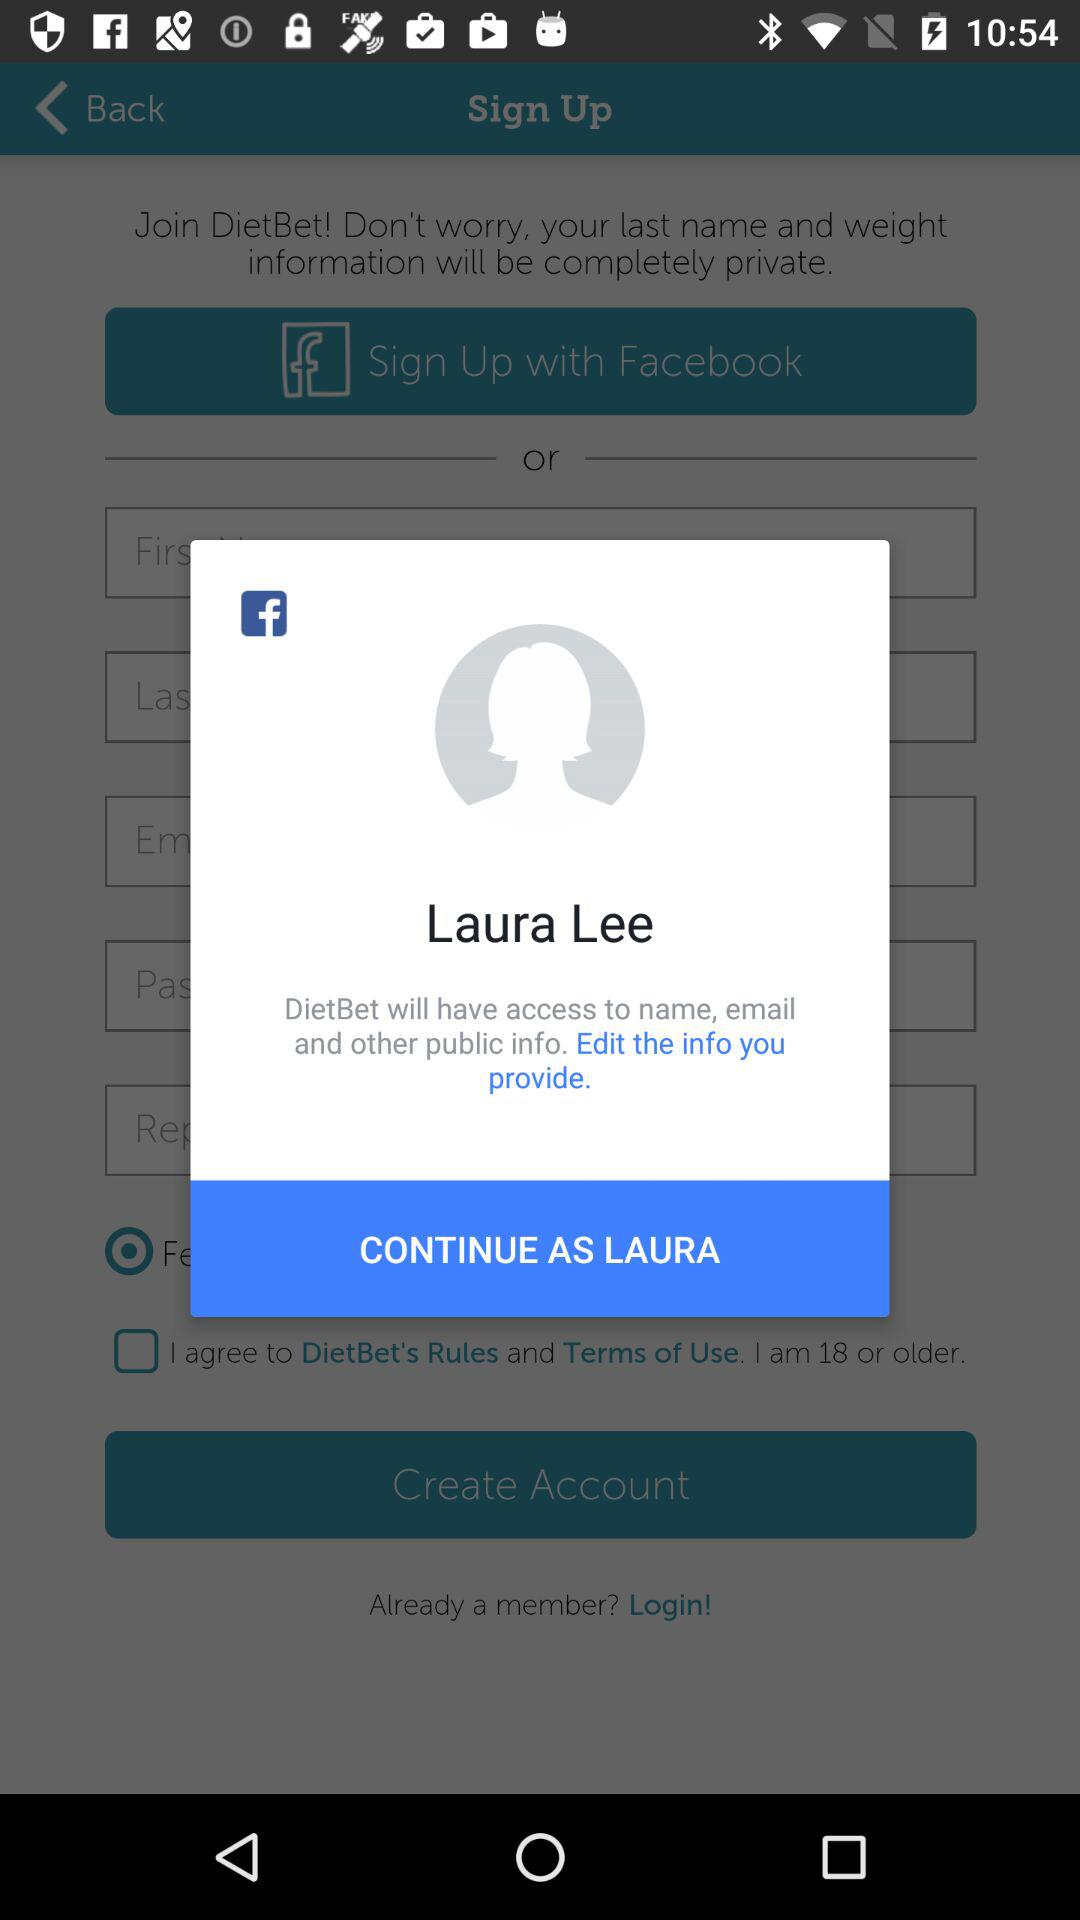Through what application can we sign up? You can sign up with "Facebook". 